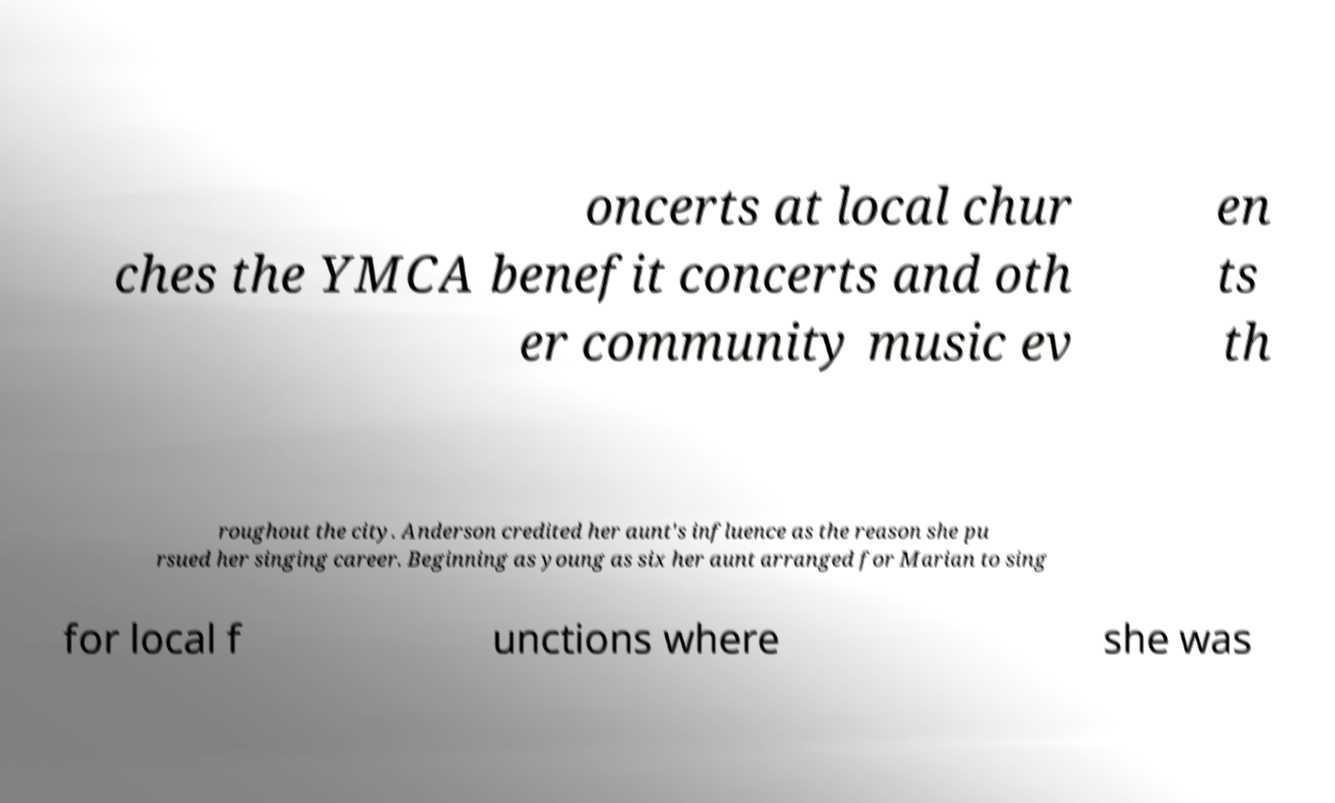Please identify and transcribe the text found in this image. oncerts at local chur ches the YMCA benefit concerts and oth er community music ev en ts th roughout the city. Anderson credited her aunt's influence as the reason she pu rsued her singing career. Beginning as young as six her aunt arranged for Marian to sing for local f unctions where she was 